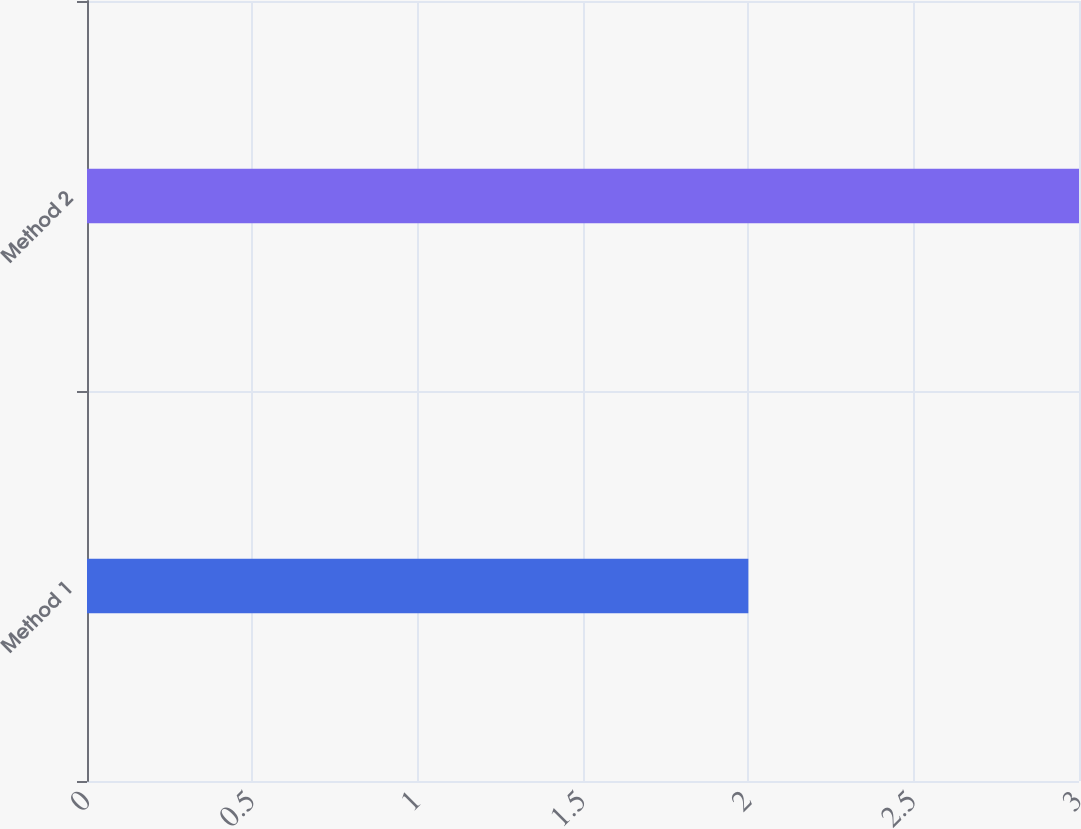Convert chart. <chart><loc_0><loc_0><loc_500><loc_500><bar_chart><fcel>Method 1<fcel>Method 2<nl><fcel>2<fcel>3<nl></chart> 